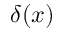Convert formula to latex. <formula><loc_0><loc_0><loc_500><loc_500>\delta ( x )</formula> 